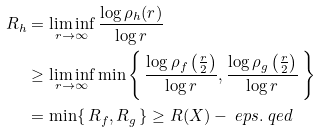Convert formula to latex. <formula><loc_0><loc_0><loc_500><loc_500>R _ { h } & = \liminf _ { r \to \infty } \frac { \log \rho _ { h } ( r ) } { \log r } \\ & \geq \liminf _ { r \to \infty } \min \left \{ \, \frac { \log \rho _ { f } \left ( \frac { r } { 2 } \right ) } { \log r } , \frac { \log \rho _ { g } \left ( \frac { r } { 2 } \right ) } { \log r } \, \right \} \\ & = \min \{ \, R _ { f } , R _ { g } \, \} \geq R ( X ) - \ e p s . \ q e d</formula> 